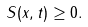Convert formula to latex. <formula><loc_0><loc_0><loc_500><loc_500>S ( x , t ) \geq 0 .</formula> 